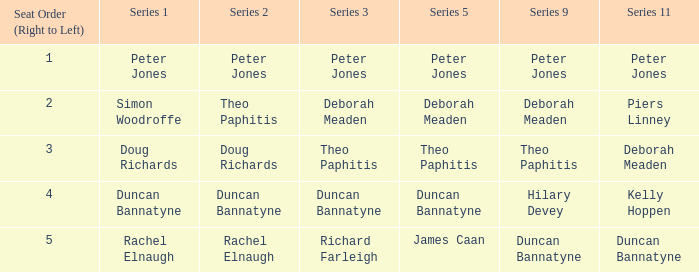Which Series 1 has a Series 11 of peter jones? Peter Jones. 